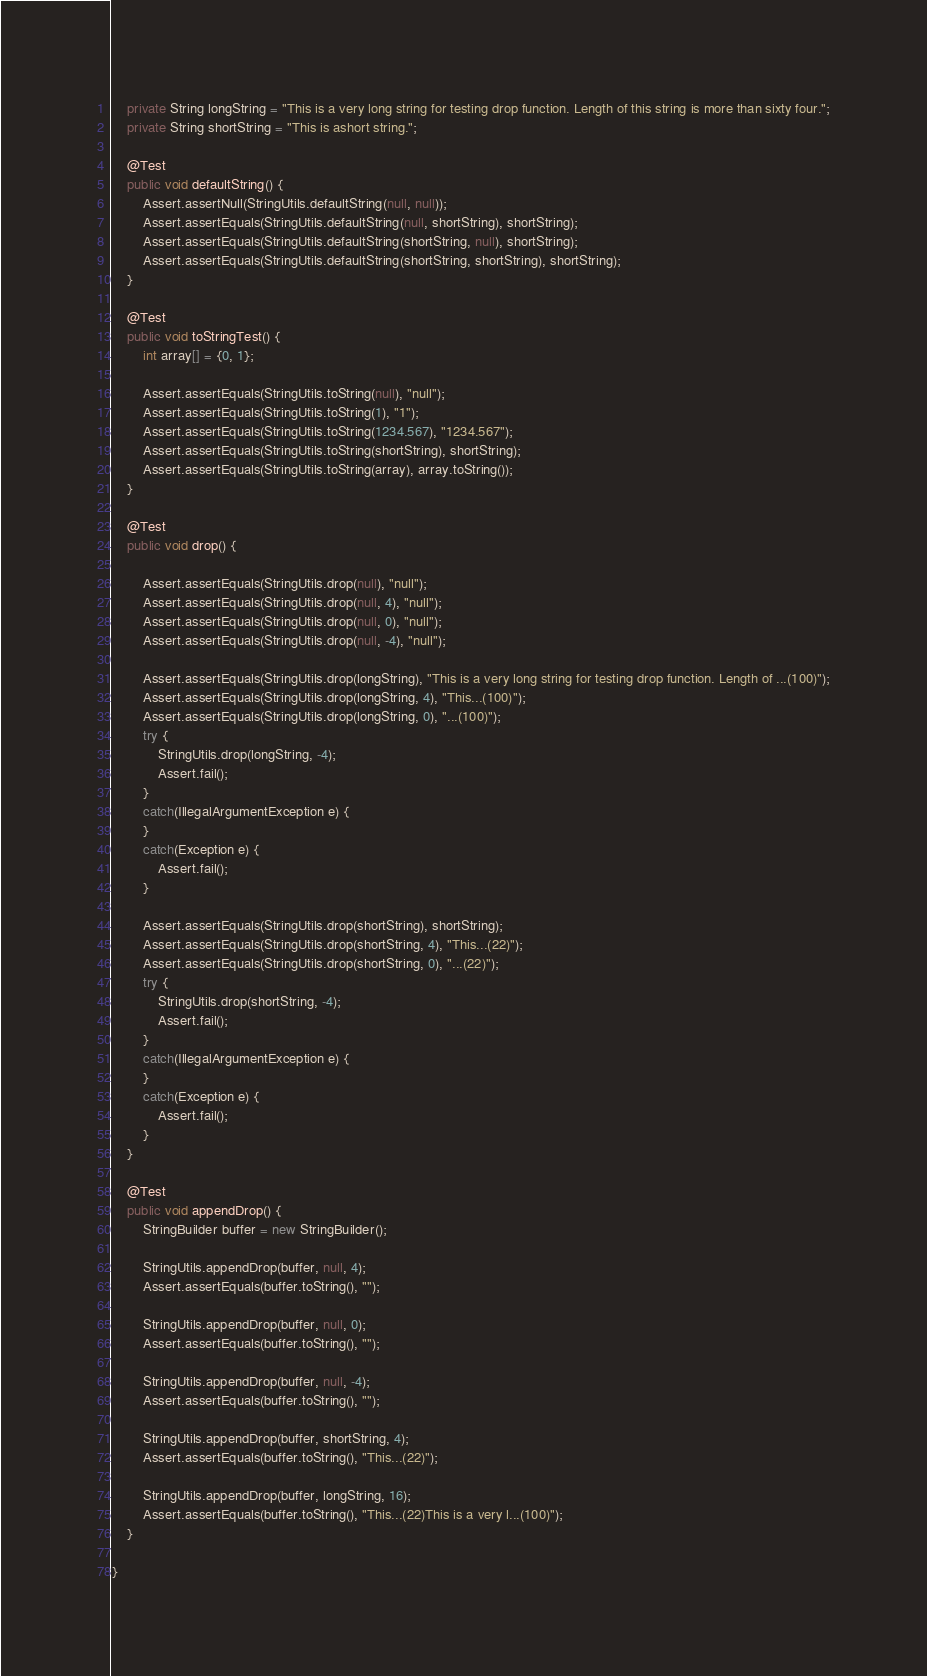<code> <loc_0><loc_0><loc_500><loc_500><_Java_>	private String longString = "This is a very long string for testing drop function. Length of this string is more than sixty four.";
	private String shortString = "This is ashort string.";

	@Test
	public void defaultString() {
		Assert.assertNull(StringUtils.defaultString(null, null));
		Assert.assertEquals(StringUtils.defaultString(null, shortString), shortString);
		Assert.assertEquals(StringUtils.defaultString(shortString, null), shortString);
		Assert.assertEquals(StringUtils.defaultString(shortString, shortString), shortString);
	}
	
	@Test
	public void toStringTest() {
		int array[] = {0, 1};

		Assert.assertEquals(StringUtils.toString(null), "null");
		Assert.assertEquals(StringUtils.toString(1), "1");
		Assert.assertEquals(StringUtils.toString(1234.567), "1234.567");
		Assert.assertEquals(StringUtils.toString(shortString), shortString);
		Assert.assertEquals(StringUtils.toString(array), array.toString());
	}
	
	@Test
	public void drop() {
		
		Assert.assertEquals(StringUtils.drop(null), "null");
		Assert.assertEquals(StringUtils.drop(null, 4), "null");
		Assert.assertEquals(StringUtils.drop(null, 0), "null");
		Assert.assertEquals(StringUtils.drop(null, -4), "null");

		Assert.assertEquals(StringUtils.drop(longString), "This is a very long string for testing drop function. Length of ...(100)");
		Assert.assertEquals(StringUtils.drop(longString, 4), "This...(100)");
		Assert.assertEquals(StringUtils.drop(longString, 0), "...(100)");
		try {
			StringUtils.drop(longString, -4);
			Assert.fail();
		}
		catch(IllegalArgumentException e) {
		}
		catch(Exception e) {
			Assert.fail();
		}

		Assert.assertEquals(StringUtils.drop(shortString), shortString);
		Assert.assertEquals(StringUtils.drop(shortString, 4), "This...(22)");
		Assert.assertEquals(StringUtils.drop(shortString, 0), "...(22)");
		try {
			StringUtils.drop(shortString, -4);
			Assert.fail();
		}
		catch(IllegalArgumentException e) {
		}
		catch(Exception e) {
			Assert.fail();
		}
	}
	
	@Test
	public void appendDrop() {
		StringBuilder buffer = new StringBuilder();

		StringUtils.appendDrop(buffer, null, 4);
		Assert.assertEquals(buffer.toString(), "");

		StringUtils.appendDrop(buffer, null, 0);
		Assert.assertEquals(buffer.toString(), "");

		StringUtils.appendDrop(buffer, null, -4);
		Assert.assertEquals(buffer.toString(), "");

		StringUtils.appendDrop(buffer, shortString, 4);
		Assert.assertEquals(buffer.toString(), "This...(22)");

		StringUtils.appendDrop(buffer, longString, 16);
		Assert.assertEquals(buffer.toString(), "This...(22)This is a very l...(100)");
	}

}
</code> 